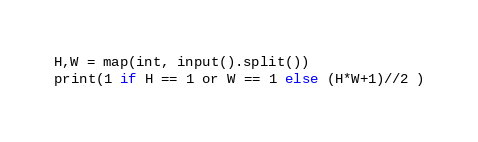Convert code to text. <code><loc_0><loc_0><loc_500><loc_500><_Python_>H,W = map(int, input().split())
print(1 if H == 1 or W == 1 else (H*W+1)//2 )</code> 